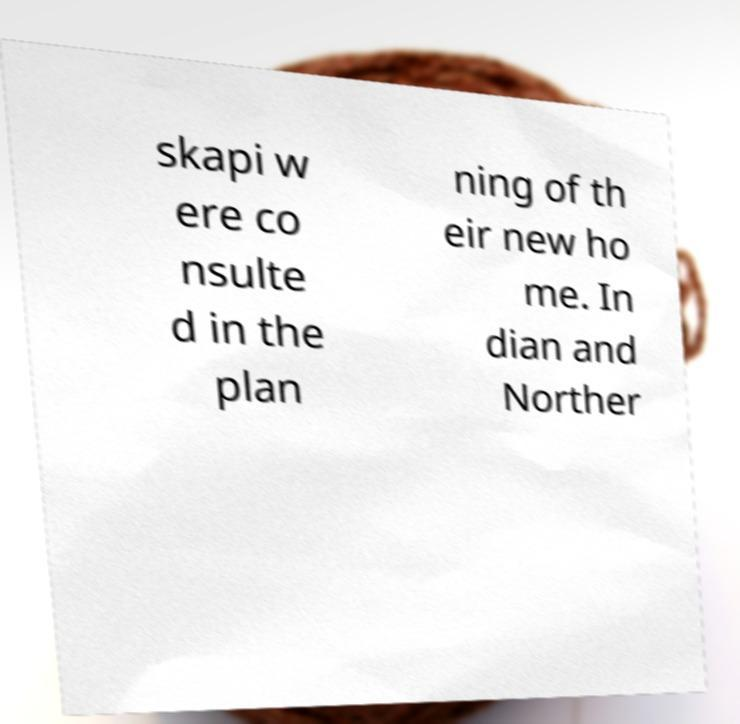Could you assist in decoding the text presented in this image and type it out clearly? skapi w ere co nsulte d in the plan ning of th eir new ho me. In dian and Norther 